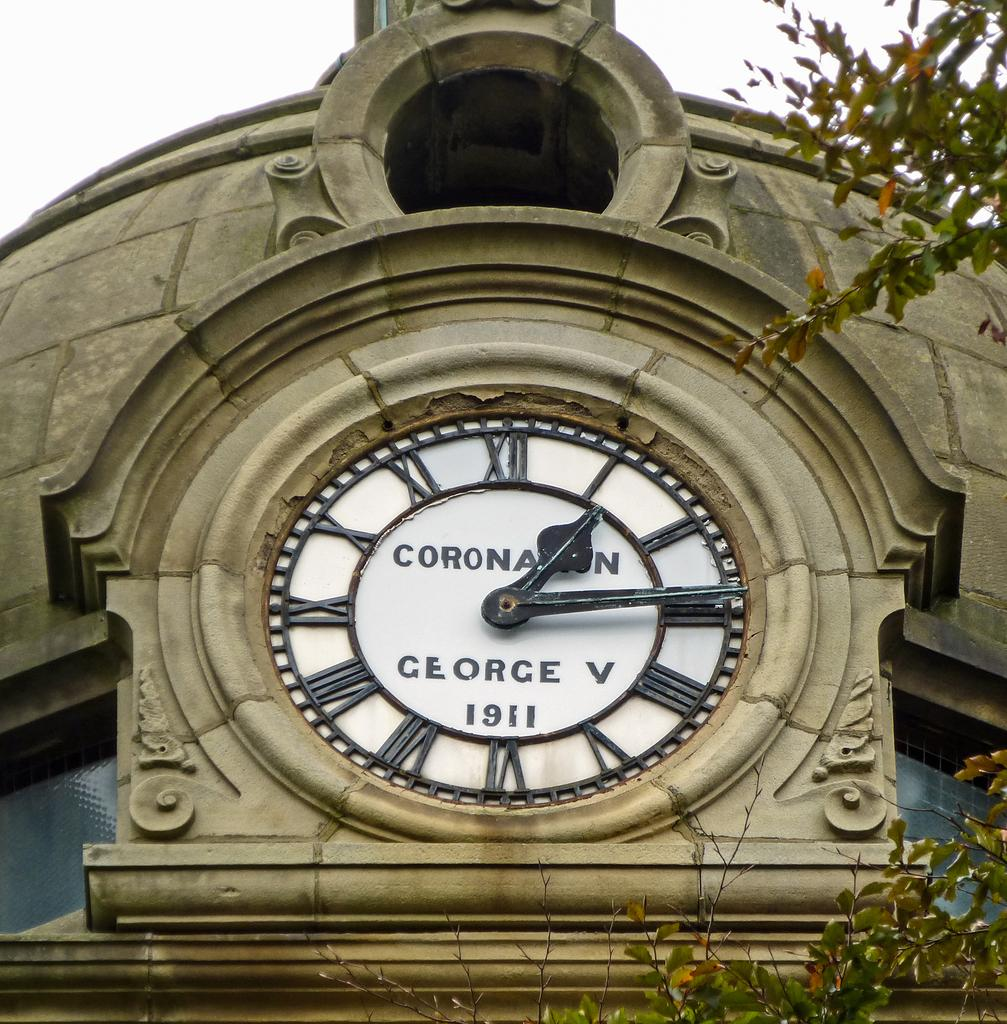Provide a one-sentence caption for the provided image. old timeless clock displayed outside coranation  george v. 